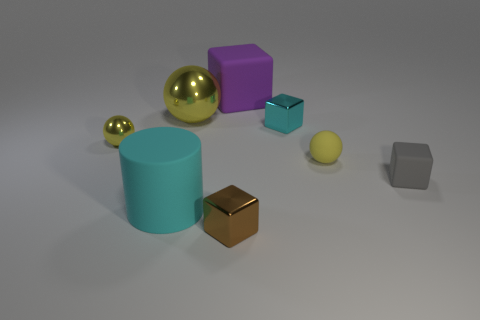Subtract all tiny yellow matte spheres. How many spheres are left? 2 Add 2 tiny blue things. How many objects exist? 10 Subtract all balls. How many objects are left? 5 Subtract 1 cylinders. How many cylinders are left? 0 Subtract all blue cylinders. Subtract all gray blocks. How many cylinders are left? 1 Subtract all brown balls. How many brown blocks are left? 1 Subtract all tiny brown matte objects. Subtract all large rubber cylinders. How many objects are left? 7 Add 3 big yellow shiny objects. How many big yellow shiny objects are left? 4 Add 8 small blue cubes. How many small blue cubes exist? 8 Subtract all gray cubes. How many cubes are left? 3 